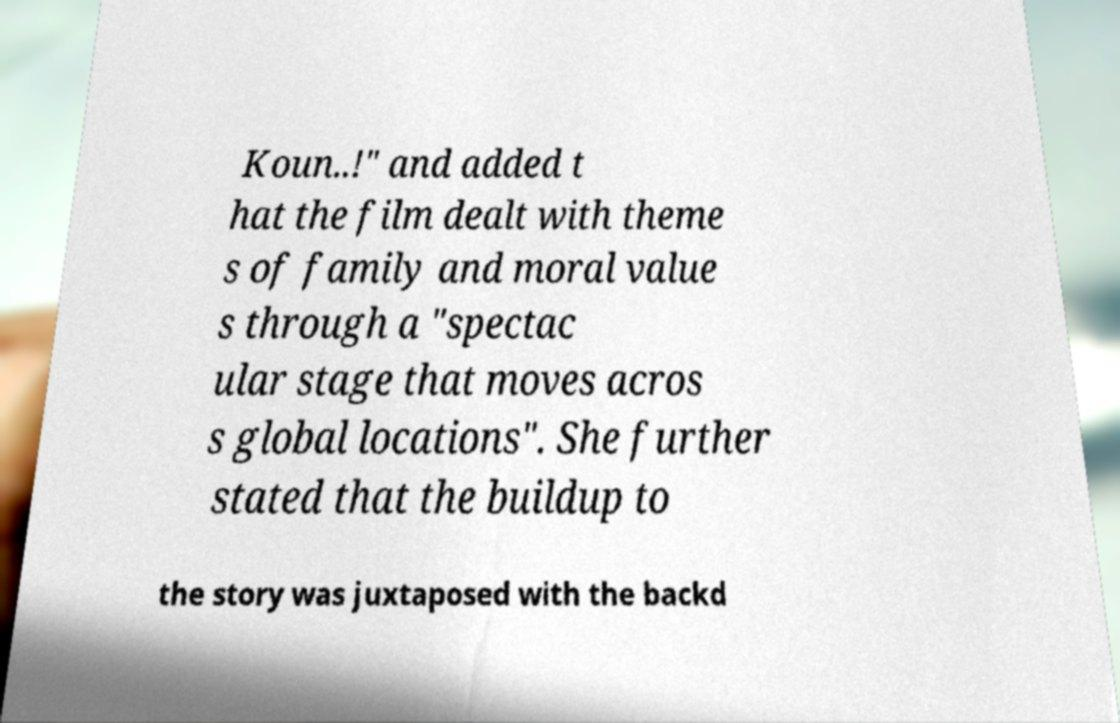I need the written content from this picture converted into text. Can you do that? Koun..!" and added t hat the film dealt with theme s of family and moral value s through a "spectac ular stage that moves acros s global locations". She further stated that the buildup to the story was juxtaposed with the backd 